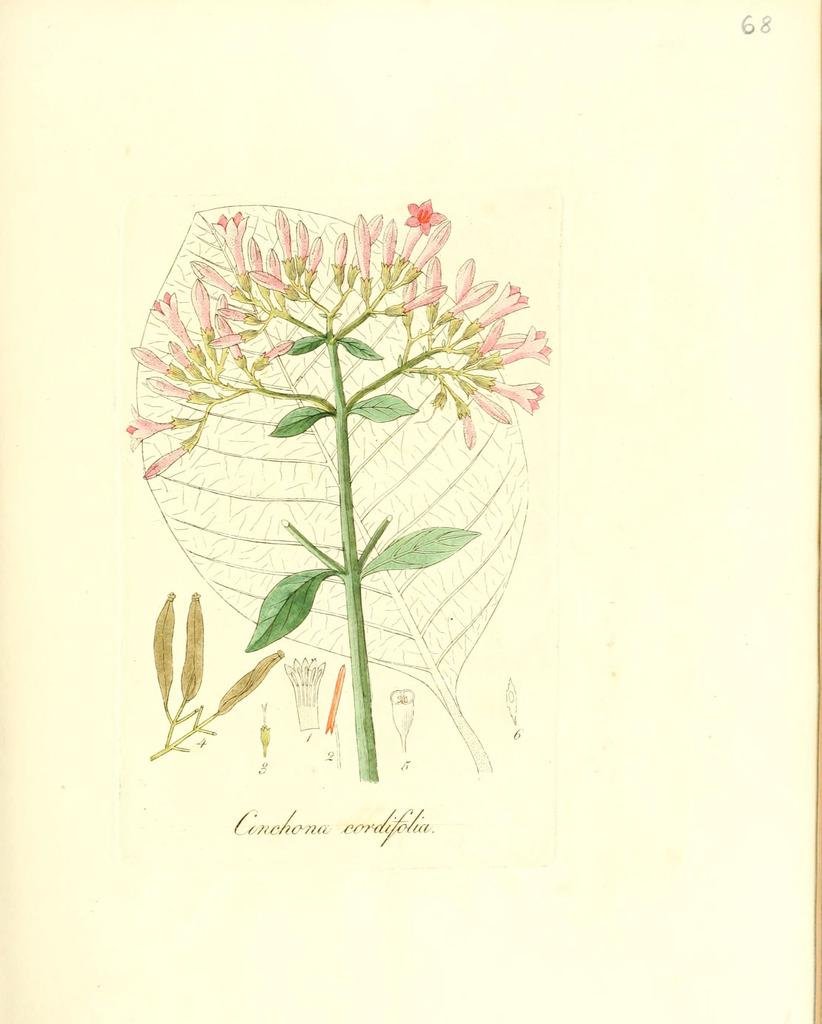What is the medium of the image? The image is a sketch on a paper. What is the main subject of the sketch? The sketch features a stem, flowers, and leaves. Is there any text present in the sketch? Yes, there is text in the sketch. How many rabbits can be seen in the sketch? There are no rabbits present in the sketch; it features a stem, flowers, and leaves. What type of ant is crawling on the horse in the sketch? There is no horse or ant present in the sketch; it only contains a stem, flowers, and leaves. 